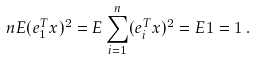Convert formula to latex. <formula><loc_0><loc_0><loc_500><loc_500>n E ( e _ { 1 } ^ { T } x ) ^ { 2 } = E \sum _ { i = 1 } ^ { n } ( e _ { i } ^ { T } x ) ^ { 2 } = E 1 = 1 \, .</formula> 